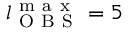<formula> <loc_0><loc_0><loc_500><loc_500>l _ { O B S } ^ { m a x } = 5</formula> 